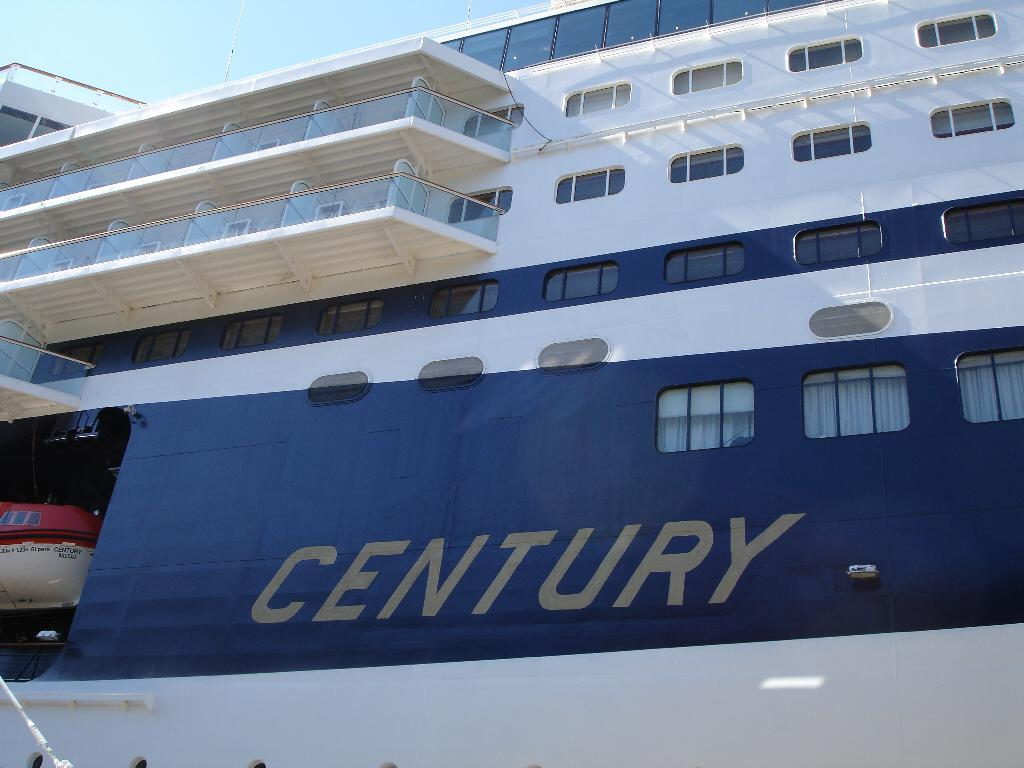What is the main subject of the image? The main subject of the image is a ship. What specific features can be seen on the ship? The ship has windows and corridors. What is visible at the top of the image? The sky is visible at the top of the image. How many fingers can be seen on the ship in the image? There are no fingers visible on the ship in the image. What type of border is present around the ship in the image? There is no border present around the ship in the image. 